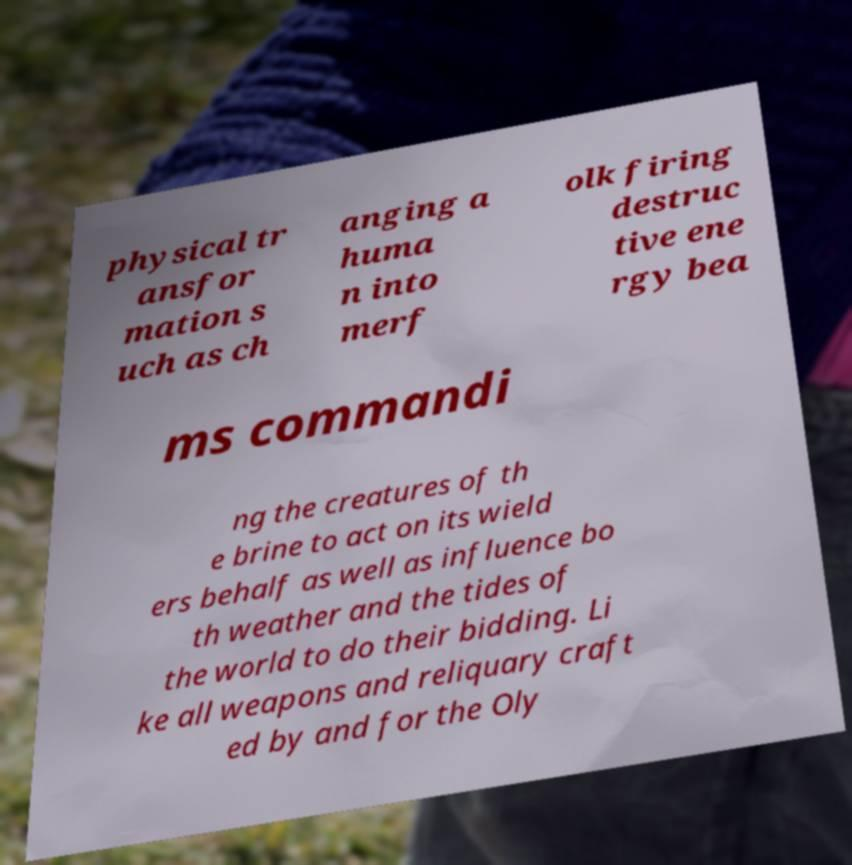I need the written content from this picture converted into text. Can you do that? physical tr ansfor mation s uch as ch anging a huma n into merf olk firing destruc tive ene rgy bea ms commandi ng the creatures of th e brine to act on its wield ers behalf as well as influence bo th weather and the tides of the world to do their bidding. Li ke all weapons and reliquary craft ed by and for the Oly 